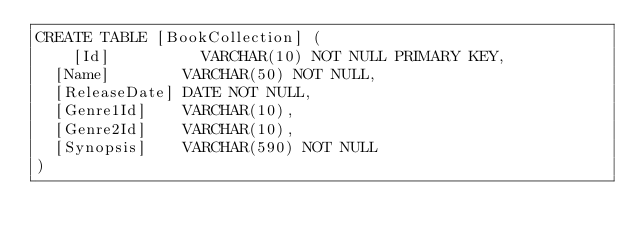Convert code to text. <code><loc_0><loc_0><loc_500><loc_500><_SQL_>CREATE TABLE [BookCollection] (
    [Id]          VARCHAR(10) NOT NULL PRIMARY KEY,
	[Name]        VARCHAR(50) NOT NULL,
	[ReleaseDate] DATE NOT NULL,
	[Genre1Id]    VARCHAR(10),
	[Genre2Id]    VARCHAR(10),
	[Synopsis]    VARCHAR(590) NOT NULL
)
</code> 